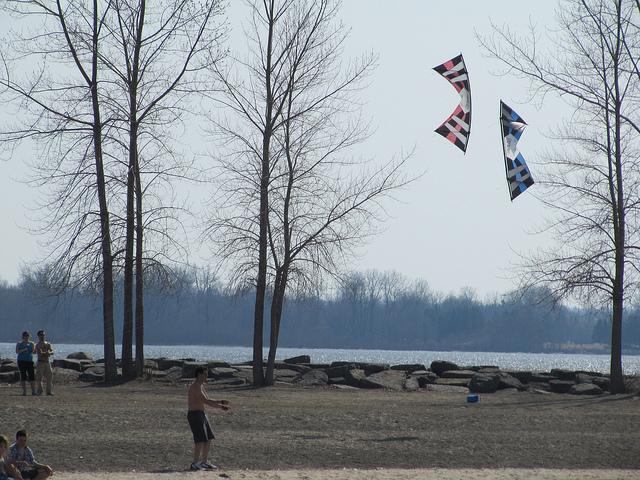What are the kites in most danger of getting stuck in?
Select the accurate response from the four choices given to answer the question.
Options: Sand, trees, water, rocks. Trees. 